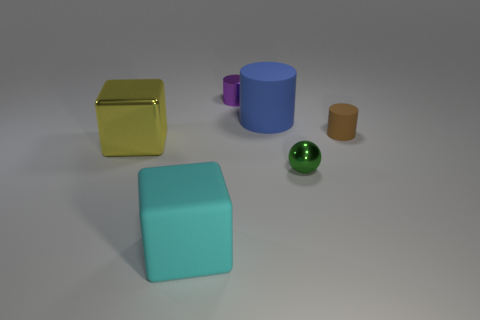Subtract all red cubes. Subtract all brown balls. How many cubes are left? 2 Add 2 large objects. How many objects exist? 8 Subtract all cubes. How many objects are left? 4 Add 6 large blue rubber cylinders. How many large blue rubber cylinders exist? 7 Subtract 0 green blocks. How many objects are left? 6 Subtract all big yellow metal blocks. Subtract all big yellow shiny objects. How many objects are left? 4 Add 4 brown cylinders. How many brown cylinders are left? 5 